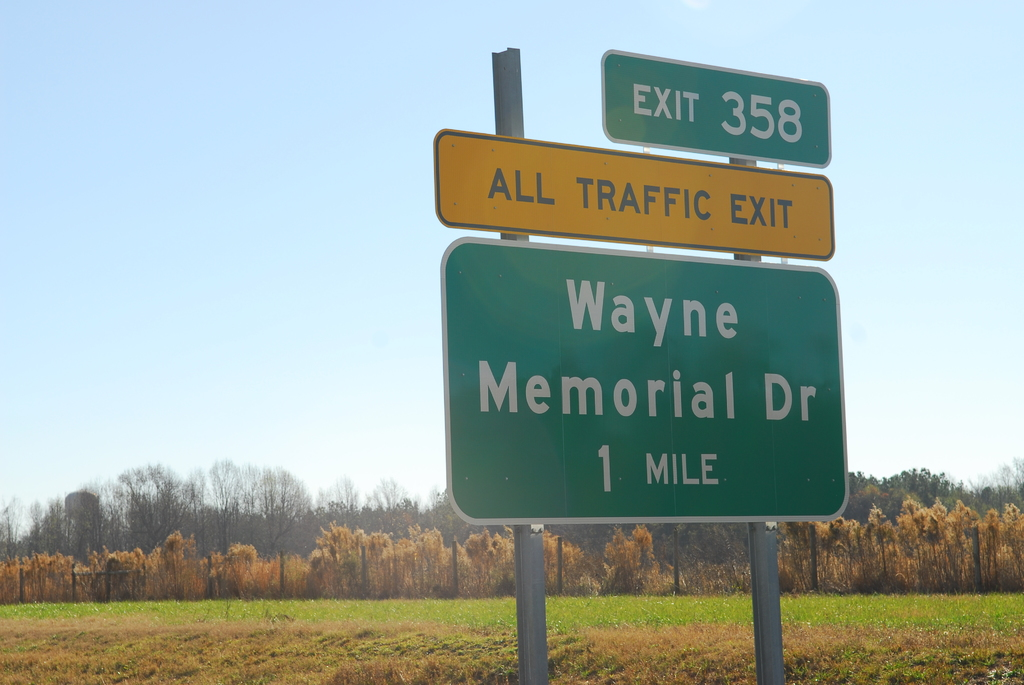Why does the sign say 'ALL TRAFFIC EXIT'? The 'ALL TRAFFIC EXIT' label on the sign likely indicates either an impending road closure or a rerouting of traffic. This could be due to road construction, an accident further along the highway, or special events in the area which might require all vehicles to detour via Wayne Memorial Drive. Such instructions help manage traffic flow while minimizing congestions or dangerous conditions down the road. 